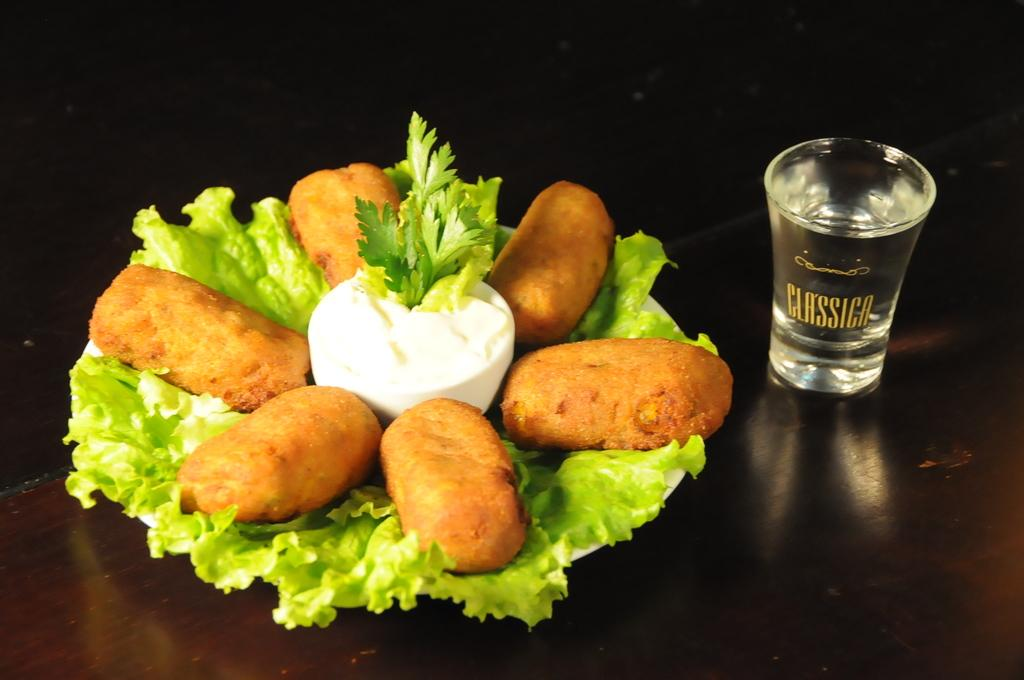What piece of furniture is present in the image? There is a table in the image. What is placed on the table? There is a plate and a glass on the table. What is on the plate? There are dishes on the plate. What type of cushion is used to support the table in the image? There is no cushion present in the image, and the table is not supported by any cushion. 